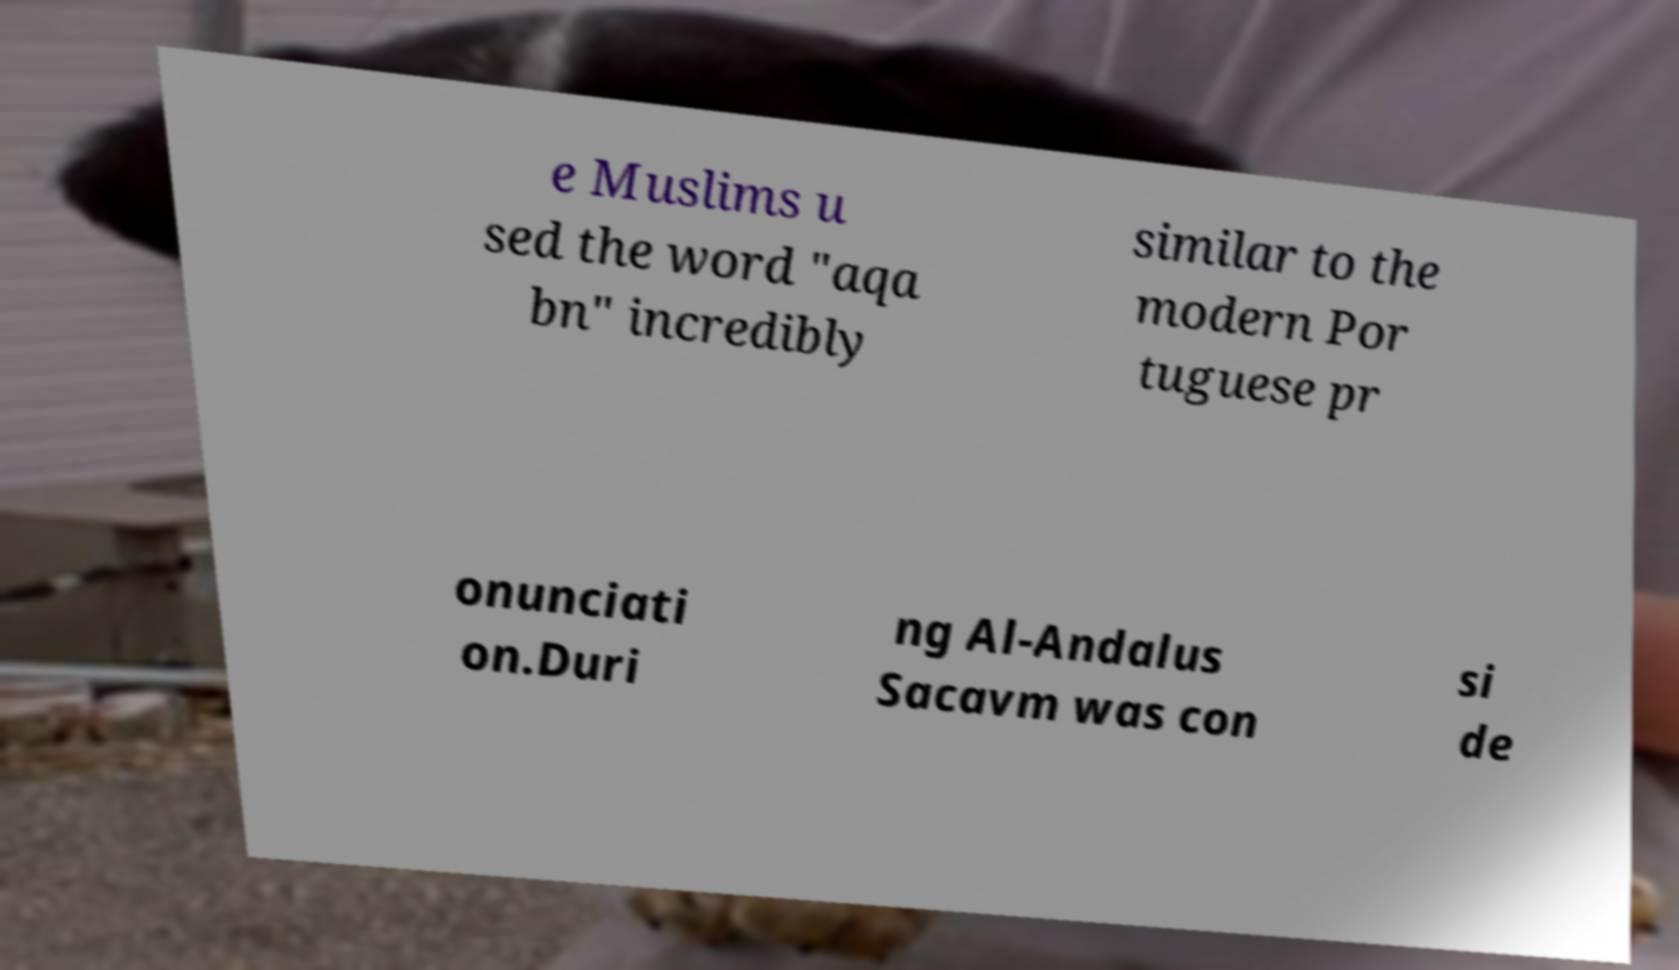Please identify and transcribe the text found in this image. e Muslims u sed the word "aqa bn" incredibly similar to the modern Por tuguese pr onunciati on.Duri ng Al-Andalus Sacavm was con si de 